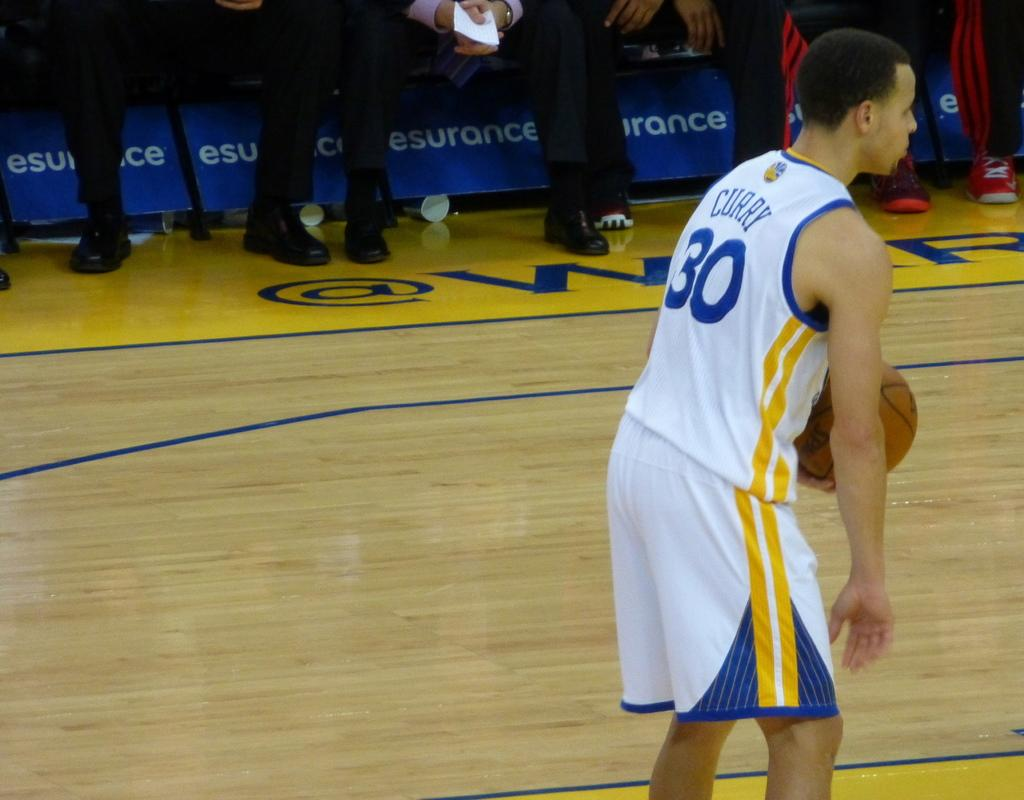<image>
Describe the image concisely. Number thirty Steve Curry on the basketball court holding a basketball. 